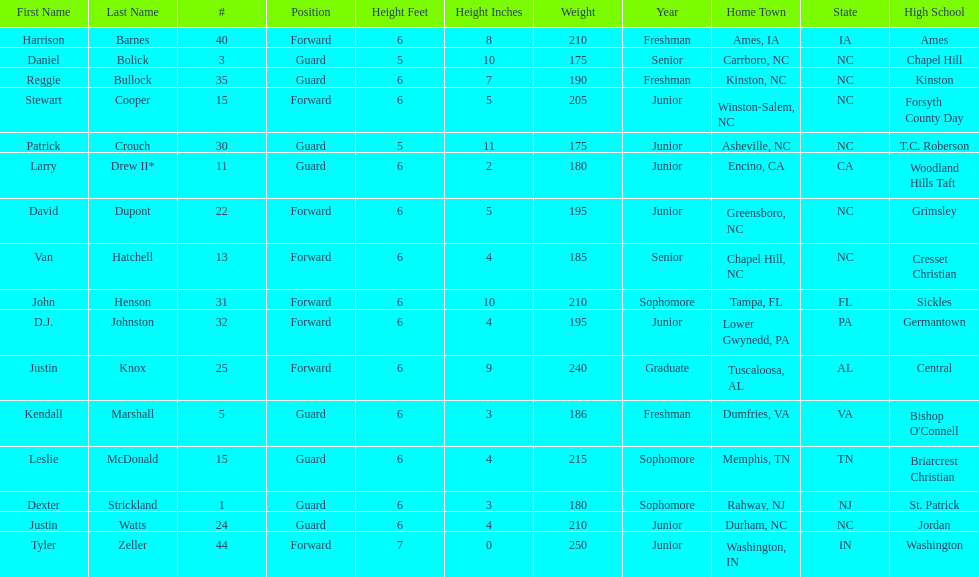How many players are not a junior? 9. 